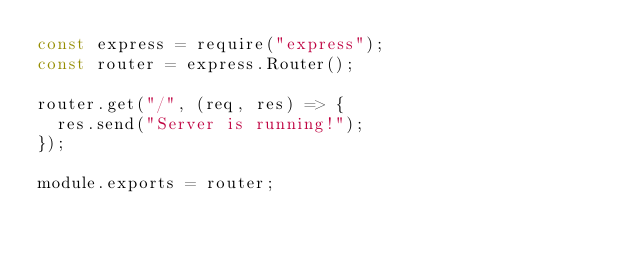Convert code to text. <code><loc_0><loc_0><loc_500><loc_500><_JavaScript_>const express = require("express");
const router = express.Router();

router.get("/", (req, res) => {
  res.send("Server is running!");
});

module.exports = router;
</code> 